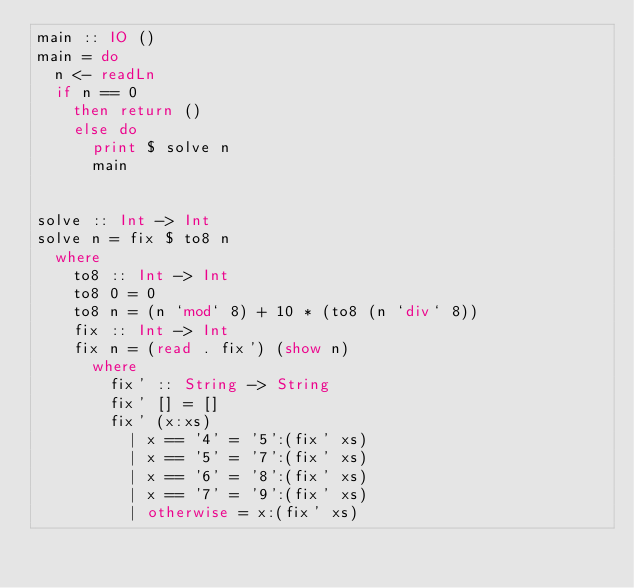Convert code to text. <code><loc_0><loc_0><loc_500><loc_500><_Haskell_>main :: IO ()
main = do
  n <- readLn
  if n == 0
    then return ()
    else do
      print $ solve n
      main


solve :: Int -> Int
solve n = fix $ to8 n
  where
    to8 :: Int -> Int
    to8 0 = 0
    to8 n = (n `mod` 8) + 10 * (to8 (n `div` 8))
    fix :: Int -> Int
    fix n = (read . fix') (show n)
      where
        fix' :: String -> String
        fix' [] = []
        fix' (x:xs)
          | x == '4' = '5':(fix' xs)
          | x == '5' = '7':(fix' xs)
          | x == '6' = '8':(fix' xs)
          | x == '7' = '9':(fix' xs)
          | otherwise = x:(fix' xs)</code> 